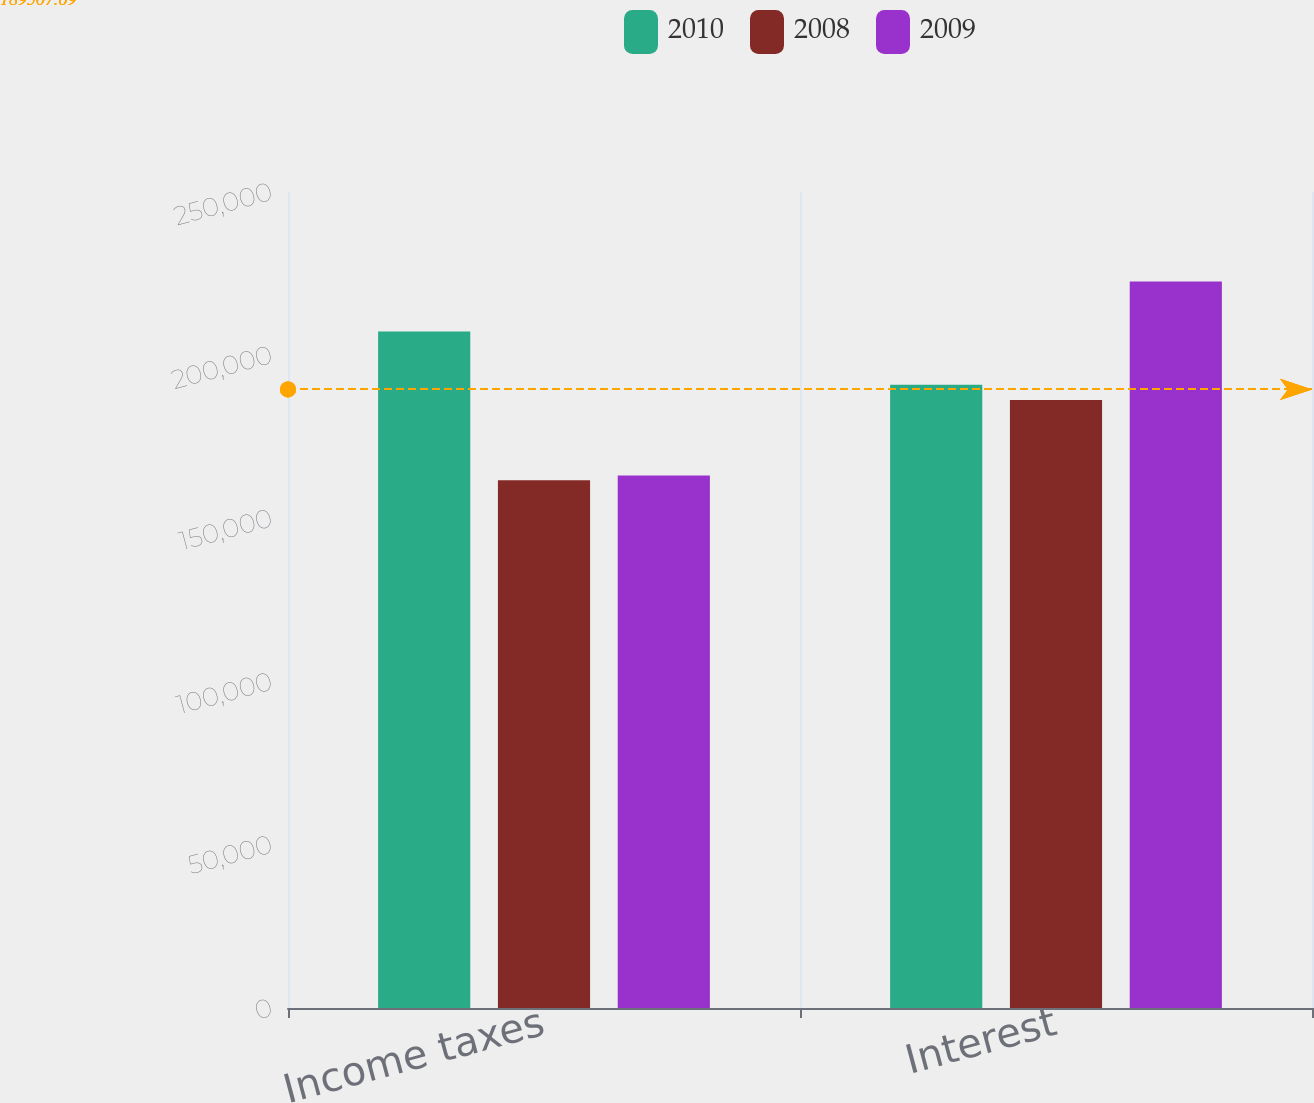Convert chart to OTSL. <chart><loc_0><loc_0><loc_500><loc_500><stacked_bar_chart><ecel><fcel>Income taxes<fcel>Interest<nl><fcel>2010<fcel>207265<fcel>190949<nl><fcel>2008<fcel>161671<fcel>186280<nl><fcel>2009<fcel>163147<fcel>222558<nl></chart> 